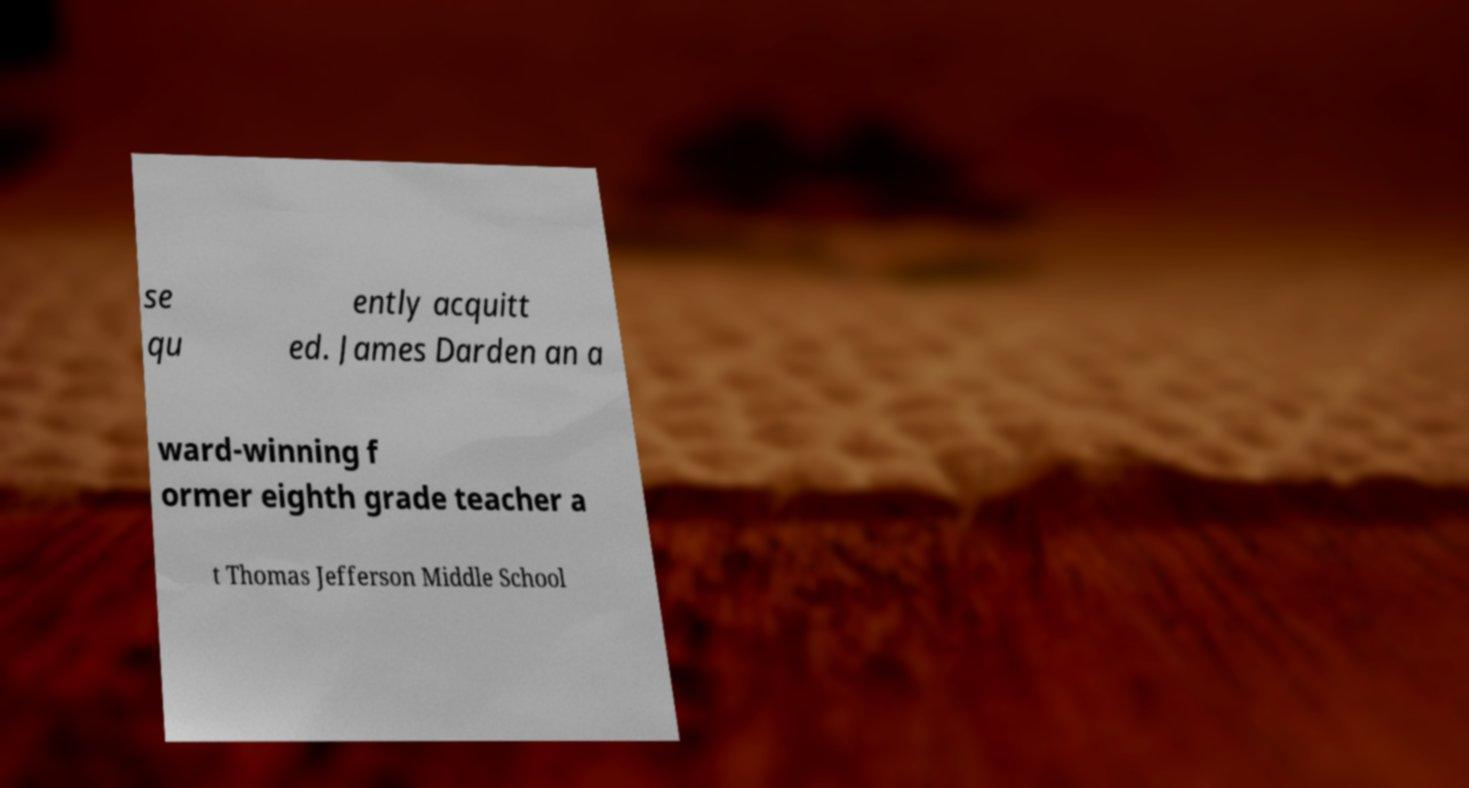Could you assist in decoding the text presented in this image and type it out clearly? se qu ently acquitt ed. James Darden an a ward-winning f ormer eighth grade teacher a t Thomas Jefferson Middle School 